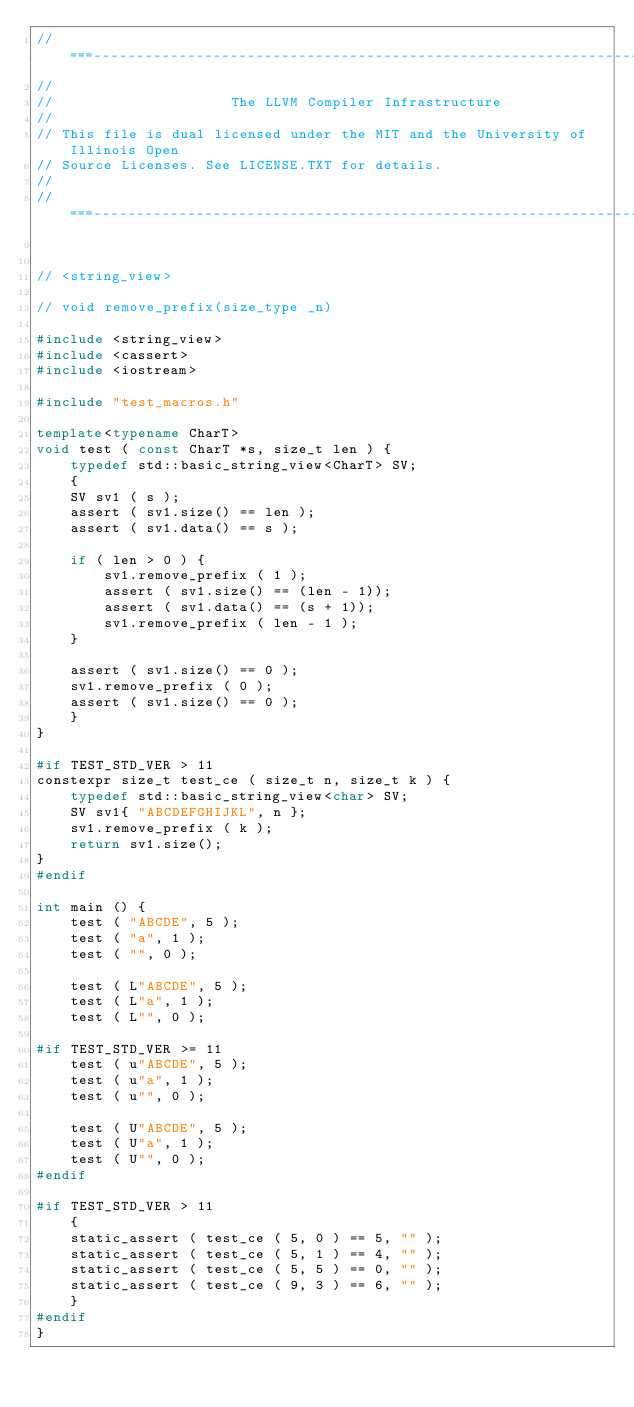<code> <loc_0><loc_0><loc_500><loc_500><_C++_>//===----------------------------------------------------------------------===//
//
//                     The LLVM Compiler Infrastructure
//
// This file is dual licensed under the MIT and the University of Illinois Open
// Source Licenses. See LICENSE.TXT for details.
//
//===----------------------------------------------------------------------===//


// <string_view>

// void remove_prefix(size_type _n)

#include <string_view>
#include <cassert>
#include <iostream>

#include "test_macros.h"

template<typename CharT>
void test ( const CharT *s, size_t len ) {
    typedef std::basic_string_view<CharT> SV;
    {
    SV sv1 ( s );
    assert ( sv1.size() == len );
    assert ( sv1.data() == s );

    if ( len > 0 ) {
        sv1.remove_prefix ( 1 );
        assert ( sv1.size() == (len - 1));
        assert ( sv1.data() == (s + 1));
        sv1.remove_prefix ( len - 1 );
    }

    assert ( sv1.size() == 0 );
    sv1.remove_prefix ( 0 );
    assert ( sv1.size() == 0 );
    }
}

#if TEST_STD_VER > 11
constexpr size_t test_ce ( size_t n, size_t k ) {
    typedef std::basic_string_view<char> SV;
    SV sv1{ "ABCDEFGHIJKL", n };
    sv1.remove_prefix ( k );
    return sv1.size();
}
#endif

int main () {
    test ( "ABCDE", 5 );
    test ( "a", 1 );
    test ( "", 0 );

    test ( L"ABCDE", 5 );
    test ( L"a", 1 );
    test ( L"", 0 );

#if TEST_STD_VER >= 11
    test ( u"ABCDE", 5 );
    test ( u"a", 1 );
    test ( u"", 0 );

    test ( U"ABCDE", 5 );
    test ( U"a", 1 );
    test ( U"", 0 );
#endif

#if TEST_STD_VER > 11
    {
    static_assert ( test_ce ( 5, 0 ) == 5, "" );
    static_assert ( test_ce ( 5, 1 ) == 4, "" );
    static_assert ( test_ce ( 5, 5 ) == 0, "" );
    static_assert ( test_ce ( 9, 3 ) == 6, "" );
    }
#endif
}
</code> 